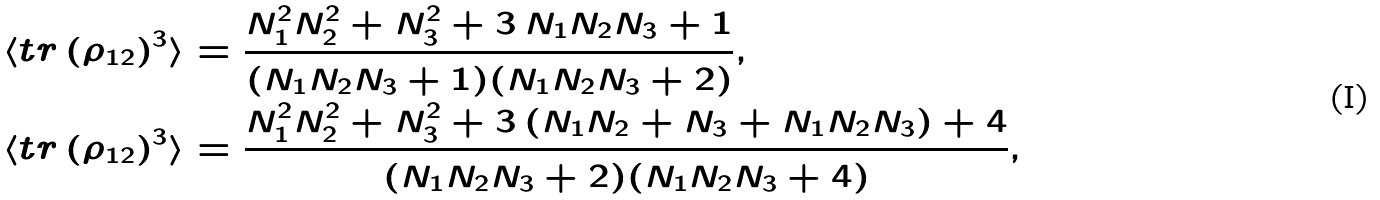Convert formula to latex. <formula><loc_0><loc_0><loc_500><loc_500>\langle t r \left ( \rho _ { 1 2 } \right ) ^ { 3 } \rangle & = \frac { N _ { 1 } ^ { 2 } N _ { 2 } ^ { 2 } + N _ { 3 } ^ { 2 } + 3 \, N _ { 1 } N _ { 2 } N _ { 3 } + 1 } { ( N _ { 1 } N _ { 2 } N _ { 3 } + 1 ) ( N _ { 1 } N _ { 2 } N _ { 3 } + 2 ) } , \\ \langle t r \left ( \rho _ { 1 2 } \right ) ^ { 3 } \rangle & = \frac { N _ { 1 } ^ { 2 } N _ { 2 } ^ { 2 } + N _ { 3 } ^ { 2 } + 3 \, ( N _ { 1 } N _ { 2 } + N _ { 3 } + N _ { 1 } N _ { 2 } N _ { 3 } ) + 4 } { ( N _ { 1 } N _ { 2 } N _ { 3 } + 2 ) ( N _ { 1 } N _ { 2 } N _ { 3 } + 4 ) } ,</formula> 